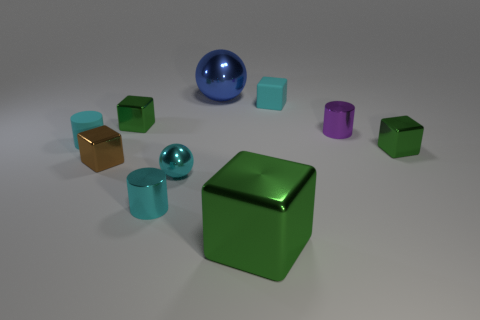Are the blue thing and the small cyan cube made of the same material?
Keep it short and to the point. No. The matte thing that is the same shape as the purple metallic object is what size?
Offer a very short reply. Small. There is a green metal thing to the left of the cyan shiny ball; is its shape the same as the green thing in front of the brown shiny object?
Your answer should be very brief. Yes. There is a blue shiny ball; is it the same size as the matte thing that is right of the blue shiny ball?
Your answer should be compact. No. How many other things are made of the same material as the tiny cyan block?
Make the answer very short. 1. The large shiny thing that is behind the cylinder in front of the small green shiny object that is to the right of the purple metal cylinder is what color?
Provide a short and direct response. Blue. What shape is the tiny shiny object that is behind the matte cylinder and on the right side of the small matte cube?
Provide a succinct answer. Cylinder. What color is the tiny metallic cylinder that is behind the cylinder in front of the brown object?
Give a very brief answer. Purple. There is a small cyan thing that is behind the cyan object on the left side of the tiny metallic cylinder in front of the small cyan shiny ball; what is its shape?
Make the answer very short. Cube. What size is the green block that is both to the left of the purple cylinder and in front of the cyan matte cylinder?
Your answer should be compact. Large. 